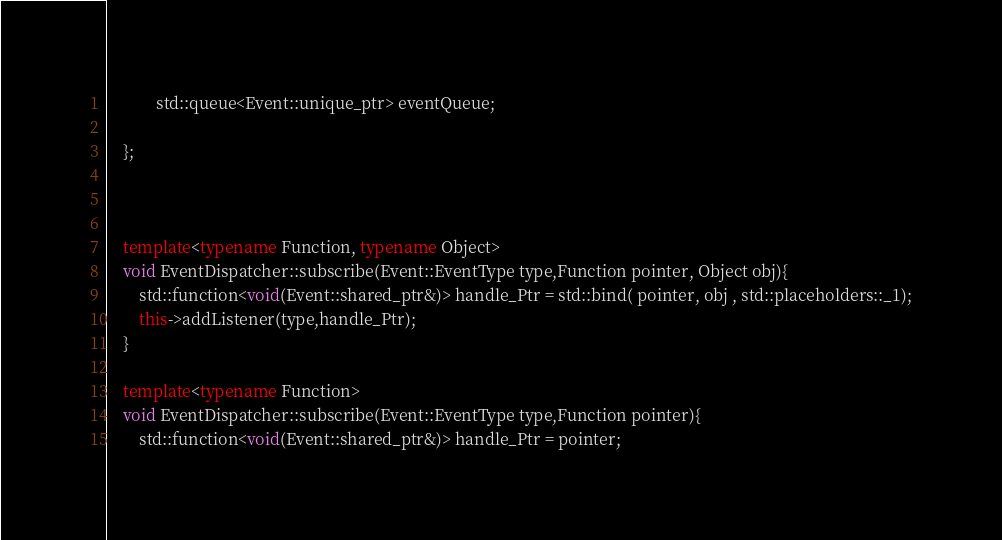Convert code to text. <code><loc_0><loc_0><loc_500><loc_500><_C++_>			std::queue<Event::unique_ptr> eventQueue;

	};



	template<typename Function, typename Object>
	void EventDispatcher::subscribe(Event::EventType type,Function pointer, Object obj){
		std::function<void(Event::shared_ptr&)> handle_Ptr = std::bind( pointer, obj , std::placeholders::_1);
		this->addListener(type,handle_Ptr);
	}

	template<typename Function>
	void EventDispatcher::subscribe(Event::EventType type,Function pointer){
		std::function<void(Event::shared_ptr&)> handle_Ptr = pointer;</code> 